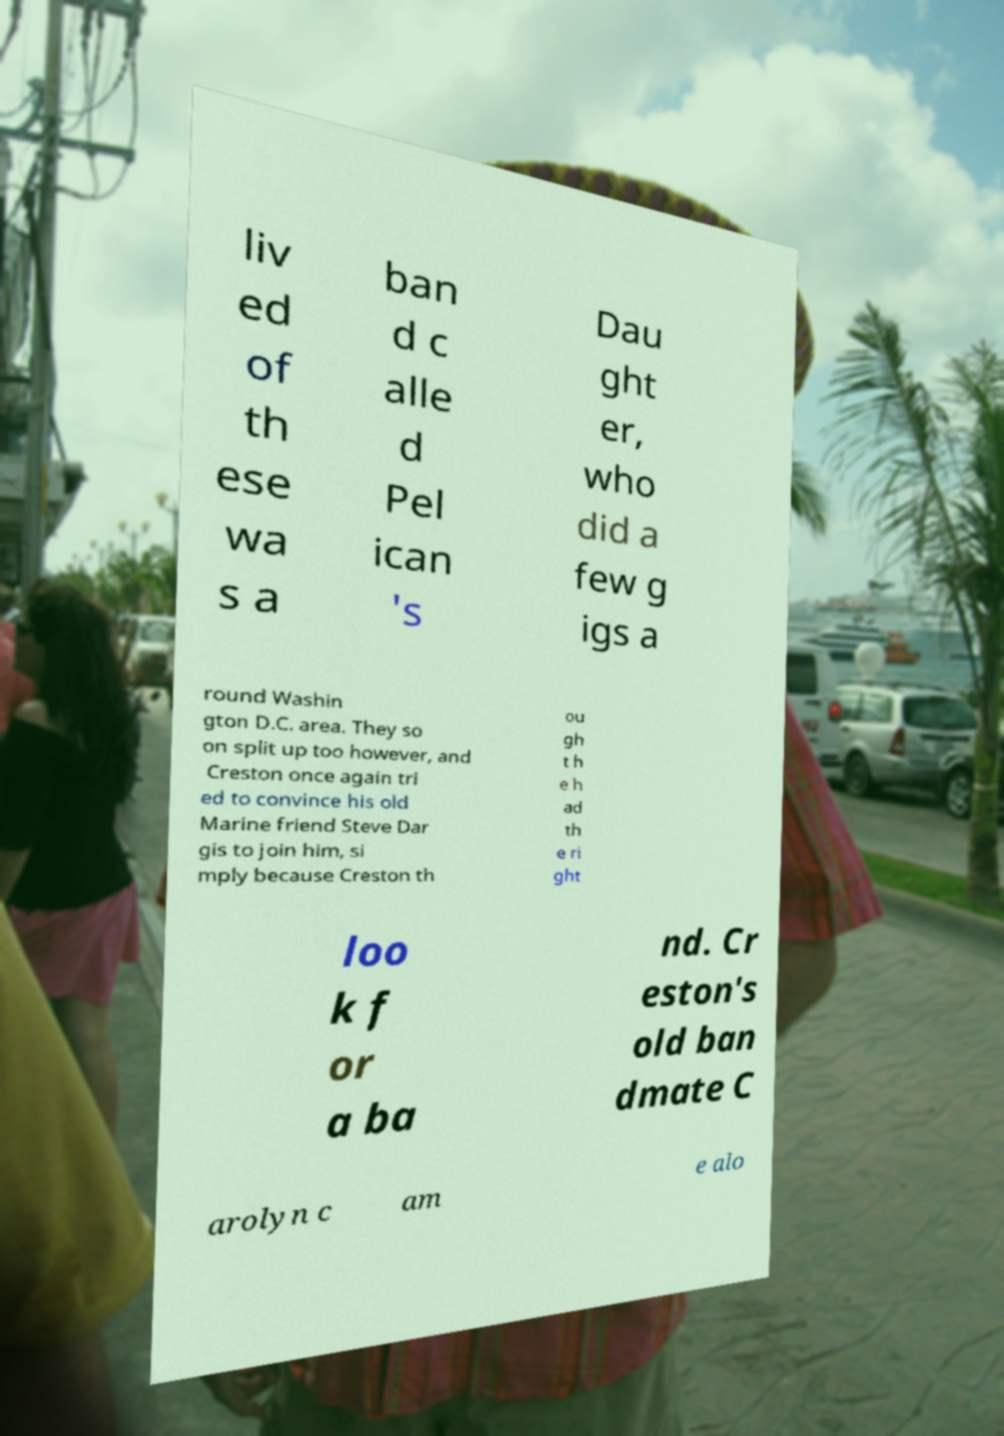What messages or text are displayed in this image? I need them in a readable, typed format. liv ed of th ese wa s a ban d c alle d Pel ican 's Dau ght er, who did a few g igs a round Washin gton D.C. area. They so on split up too however, and Creston once again tri ed to convince his old Marine friend Steve Dar gis to join him, si mply because Creston th ou gh t h e h ad th e ri ght loo k f or a ba nd. Cr eston's old ban dmate C arolyn c am e alo 